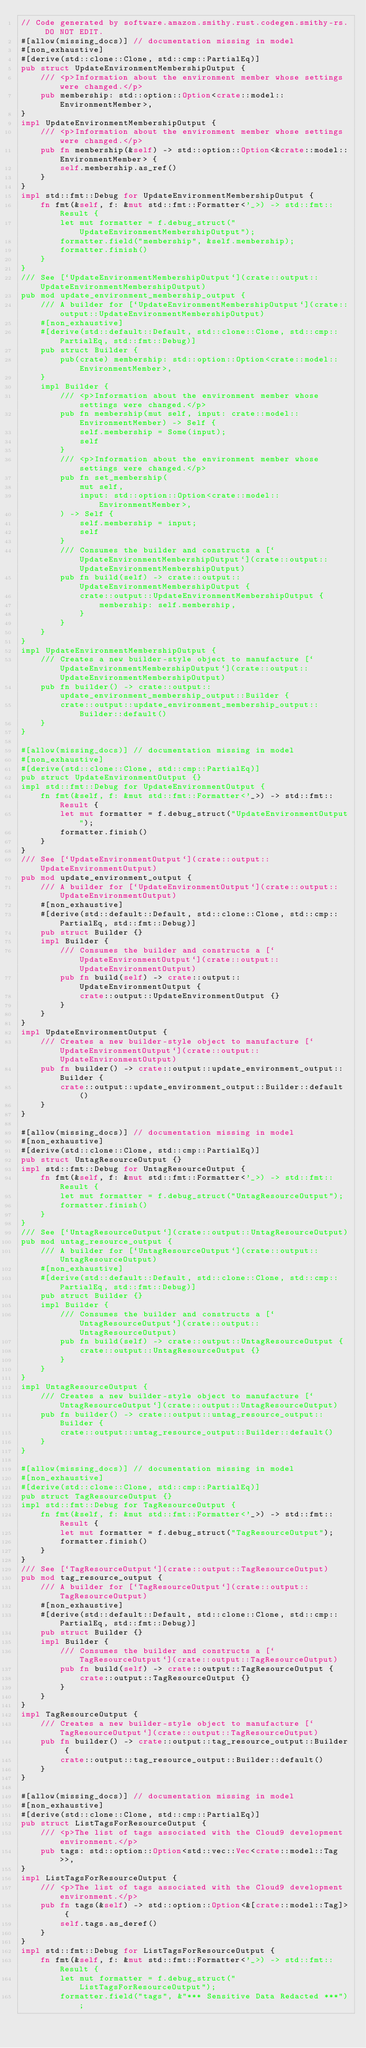Convert code to text. <code><loc_0><loc_0><loc_500><loc_500><_Rust_>// Code generated by software.amazon.smithy.rust.codegen.smithy-rs. DO NOT EDIT.
#[allow(missing_docs)] // documentation missing in model
#[non_exhaustive]
#[derive(std::clone::Clone, std::cmp::PartialEq)]
pub struct UpdateEnvironmentMembershipOutput {
    /// <p>Information about the environment member whose settings were changed.</p>
    pub membership: std::option::Option<crate::model::EnvironmentMember>,
}
impl UpdateEnvironmentMembershipOutput {
    /// <p>Information about the environment member whose settings were changed.</p>
    pub fn membership(&self) -> std::option::Option<&crate::model::EnvironmentMember> {
        self.membership.as_ref()
    }
}
impl std::fmt::Debug for UpdateEnvironmentMembershipOutput {
    fn fmt(&self, f: &mut std::fmt::Formatter<'_>) -> std::fmt::Result {
        let mut formatter = f.debug_struct("UpdateEnvironmentMembershipOutput");
        formatter.field("membership", &self.membership);
        formatter.finish()
    }
}
/// See [`UpdateEnvironmentMembershipOutput`](crate::output::UpdateEnvironmentMembershipOutput)
pub mod update_environment_membership_output {
    /// A builder for [`UpdateEnvironmentMembershipOutput`](crate::output::UpdateEnvironmentMembershipOutput)
    #[non_exhaustive]
    #[derive(std::default::Default, std::clone::Clone, std::cmp::PartialEq, std::fmt::Debug)]
    pub struct Builder {
        pub(crate) membership: std::option::Option<crate::model::EnvironmentMember>,
    }
    impl Builder {
        /// <p>Information about the environment member whose settings were changed.</p>
        pub fn membership(mut self, input: crate::model::EnvironmentMember) -> Self {
            self.membership = Some(input);
            self
        }
        /// <p>Information about the environment member whose settings were changed.</p>
        pub fn set_membership(
            mut self,
            input: std::option::Option<crate::model::EnvironmentMember>,
        ) -> Self {
            self.membership = input;
            self
        }
        /// Consumes the builder and constructs a [`UpdateEnvironmentMembershipOutput`](crate::output::UpdateEnvironmentMembershipOutput)
        pub fn build(self) -> crate::output::UpdateEnvironmentMembershipOutput {
            crate::output::UpdateEnvironmentMembershipOutput {
                membership: self.membership,
            }
        }
    }
}
impl UpdateEnvironmentMembershipOutput {
    /// Creates a new builder-style object to manufacture [`UpdateEnvironmentMembershipOutput`](crate::output::UpdateEnvironmentMembershipOutput)
    pub fn builder() -> crate::output::update_environment_membership_output::Builder {
        crate::output::update_environment_membership_output::Builder::default()
    }
}

#[allow(missing_docs)] // documentation missing in model
#[non_exhaustive]
#[derive(std::clone::Clone, std::cmp::PartialEq)]
pub struct UpdateEnvironmentOutput {}
impl std::fmt::Debug for UpdateEnvironmentOutput {
    fn fmt(&self, f: &mut std::fmt::Formatter<'_>) -> std::fmt::Result {
        let mut formatter = f.debug_struct("UpdateEnvironmentOutput");
        formatter.finish()
    }
}
/// See [`UpdateEnvironmentOutput`](crate::output::UpdateEnvironmentOutput)
pub mod update_environment_output {
    /// A builder for [`UpdateEnvironmentOutput`](crate::output::UpdateEnvironmentOutput)
    #[non_exhaustive]
    #[derive(std::default::Default, std::clone::Clone, std::cmp::PartialEq, std::fmt::Debug)]
    pub struct Builder {}
    impl Builder {
        /// Consumes the builder and constructs a [`UpdateEnvironmentOutput`](crate::output::UpdateEnvironmentOutput)
        pub fn build(self) -> crate::output::UpdateEnvironmentOutput {
            crate::output::UpdateEnvironmentOutput {}
        }
    }
}
impl UpdateEnvironmentOutput {
    /// Creates a new builder-style object to manufacture [`UpdateEnvironmentOutput`](crate::output::UpdateEnvironmentOutput)
    pub fn builder() -> crate::output::update_environment_output::Builder {
        crate::output::update_environment_output::Builder::default()
    }
}

#[allow(missing_docs)] // documentation missing in model
#[non_exhaustive]
#[derive(std::clone::Clone, std::cmp::PartialEq)]
pub struct UntagResourceOutput {}
impl std::fmt::Debug for UntagResourceOutput {
    fn fmt(&self, f: &mut std::fmt::Formatter<'_>) -> std::fmt::Result {
        let mut formatter = f.debug_struct("UntagResourceOutput");
        formatter.finish()
    }
}
/// See [`UntagResourceOutput`](crate::output::UntagResourceOutput)
pub mod untag_resource_output {
    /// A builder for [`UntagResourceOutput`](crate::output::UntagResourceOutput)
    #[non_exhaustive]
    #[derive(std::default::Default, std::clone::Clone, std::cmp::PartialEq, std::fmt::Debug)]
    pub struct Builder {}
    impl Builder {
        /// Consumes the builder and constructs a [`UntagResourceOutput`](crate::output::UntagResourceOutput)
        pub fn build(self) -> crate::output::UntagResourceOutput {
            crate::output::UntagResourceOutput {}
        }
    }
}
impl UntagResourceOutput {
    /// Creates a new builder-style object to manufacture [`UntagResourceOutput`](crate::output::UntagResourceOutput)
    pub fn builder() -> crate::output::untag_resource_output::Builder {
        crate::output::untag_resource_output::Builder::default()
    }
}

#[allow(missing_docs)] // documentation missing in model
#[non_exhaustive]
#[derive(std::clone::Clone, std::cmp::PartialEq)]
pub struct TagResourceOutput {}
impl std::fmt::Debug for TagResourceOutput {
    fn fmt(&self, f: &mut std::fmt::Formatter<'_>) -> std::fmt::Result {
        let mut formatter = f.debug_struct("TagResourceOutput");
        formatter.finish()
    }
}
/// See [`TagResourceOutput`](crate::output::TagResourceOutput)
pub mod tag_resource_output {
    /// A builder for [`TagResourceOutput`](crate::output::TagResourceOutput)
    #[non_exhaustive]
    #[derive(std::default::Default, std::clone::Clone, std::cmp::PartialEq, std::fmt::Debug)]
    pub struct Builder {}
    impl Builder {
        /// Consumes the builder and constructs a [`TagResourceOutput`](crate::output::TagResourceOutput)
        pub fn build(self) -> crate::output::TagResourceOutput {
            crate::output::TagResourceOutput {}
        }
    }
}
impl TagResourceOutput {
    /// Creates a new builder-style object to manufacture [`TagResourceOutput`](crate::output::TagResourceOutput)
    pub fn builder() -> crate::output::tag_resource_output::Builder {
        crate::output::tag_resource_output::Builder::default()
    }
}

#[allow(missing_docs)] // documentation missing in model
#[non_exhaustive]
#[derive(std::clone::Clone, std::cmp::PartialEq)]
pub struct ListTagsForResourceOutput {
    /// <p>The list of tags associated with the Cloud9 development environment.</p>
    pub tags: std::option::Option<std::vec::Vec<crate::model::Tag>>,
}
impl ListTagsForResourceOutput {
    /// <p>The list of tags associated with the Cloud9 development environment.</p>
    pub fn tags(&self) -> std::option::Option<&[crate::model::Tag]> {
        self.tags.as_deref()
    }
}
impl std::fmt::Debug for ListTagsForResourceOutput {
    fn fmt(&self, f: &mut std::fmt::Formatter<'_>) -> std::fmt::Result {
        let mut formatter = f.debug_struct("ListTagsForResourceOutput");
        formatter.field("tags", &"*** Sensitive Data Redacted ***");</code> 